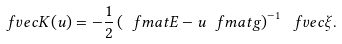<formula> <loc_0><loc_0><loc_500><loc_500>\ f v e c { K } ( u ) = - \frac { 1 } { 2 } \left ( \ f m a t { E } - u \ f m a t { g } \right ) ^ { - 1 } \ f v e c { \xi } .</formula> 